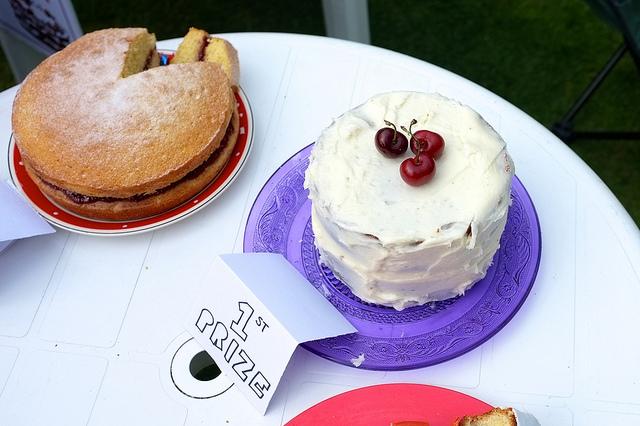What is the color of the plate?
Give a very brief answer. Purple. What color is the plate the cake that got first prize is on?
Keep it brief. Purple. Which dessert has fruit on top?
Concise answer only. Cake. How many slices are cut from the cake on the left?
Answer briefly. 1. How many cakes are pictured?
Be succinct. 2. 